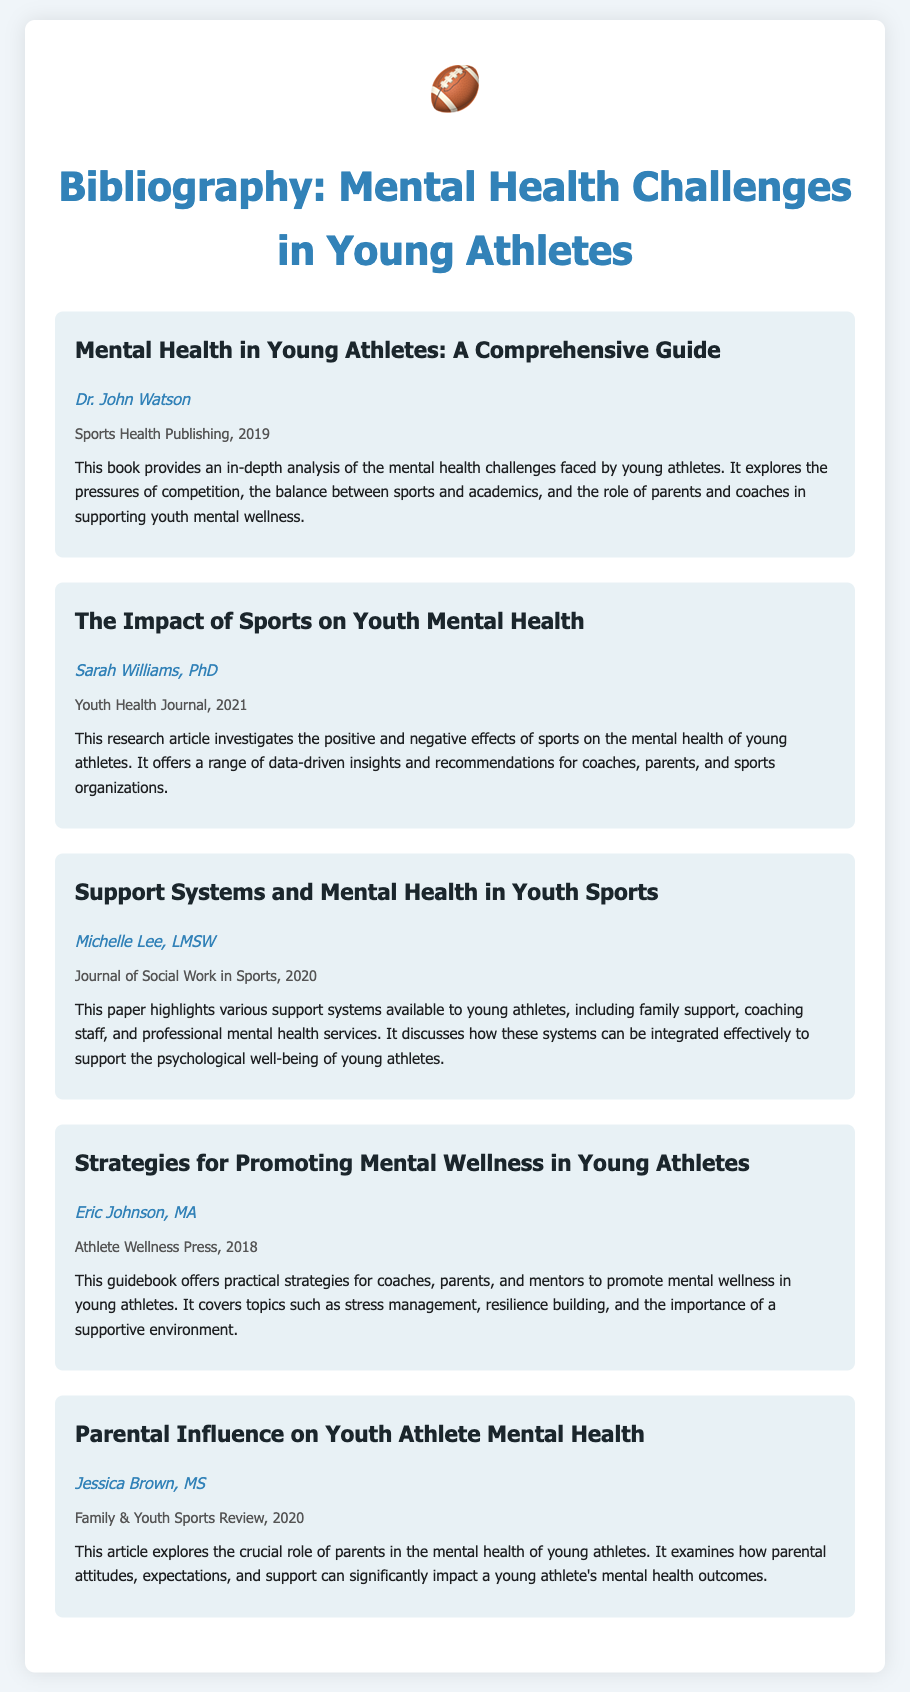What is the title of the first entry? The title of the first entry is "Mental Health in Young Athletes: A Comprehensive Guide."
Answer: Mental Health in Young Athletes: A Comprehensive Guide Who authored the entry on support systems in youth sports? The author of the entry on support systems is Michelle Lee, LMSW.
Answer: Michelle Lee, LMSW In what year was the article on parental influence published? The article on parental influence was published in 2020.
Answer: 2020 How many entries are listed in the bibliography? There are a total of five entries listed in the bibliography.
Answer: Five Which publication has the title that discusses strategies for promoting mental wellness? The publication is titled "Strategies for Promoting Mental Wellness in Young Athletes."
Answer: Strategies for Promoting Mental Wellness in Young Athletes What is the main focus of the book by Dr. John Watson? The book focuses on the mental health challenges faced by young athletes.
Answer: Mental health challenges faced by young athletes What type of publication is "Youth Health Journal"? "Youth Health Journal" is categorized as a research article.
Answer: Research article What role do parents play according to Jessica Brown's article? Parents play a crucial role in the mental health of young athletes.
Answer: Crucial role in the mental health of young athletes 